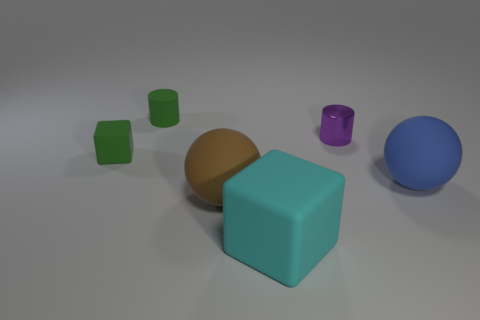Are there more purple things that are left of the tiny purple metallic cylinder than spheres behind the tiny green matte cube?
Offer a very short reply. No. What material is the thing that is behind the big blue thing and on the right side of the brown sphere?
Provide a short and direct response. Metal. Is the blue matte thing the same shape as the purple metallic object?
Your answer should be very brief. No. There is a cyan rubber cube; what number of purple metal cylinders are in front of it?
Your answer should be very brief. 0. Does the sphere that is on the left side of the purple cylinder have the same size as the cyan cube?
Provide a short and direct response. Yes. There is another object that is the same shape as the tiny purple object; what is its color?
Offer a terse response. Green. What shape is the green matte thing in front of the tiny rubber cylinder?
Your answer should be compact. Cube. How many other large things are the same shape as the blue object?
Keep it short and to the point. 1. Do the matte cube behind the brown thing and the cylinder left of the large brown rubber object have the same color?
Offer a terse response. Yes. How many things are large blue things or cyan rubber things?
Give a very brief answer. 2. 